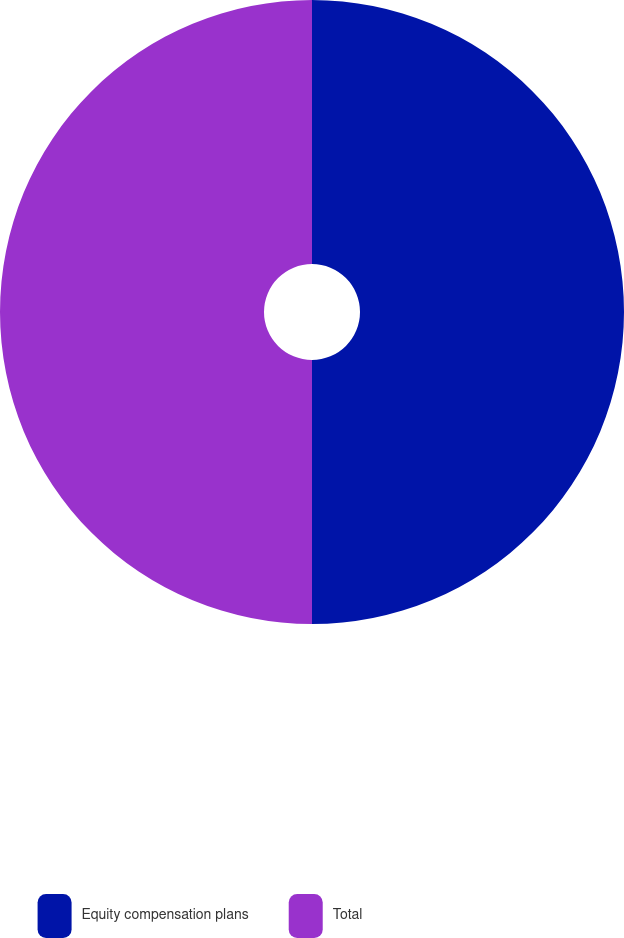Convert chart to OTSL. <chart><loc_0><loc_0><loc_500><loc_500><pie_chart><fcel>Equity compensation plans<fcel>Total<nl><fcel>50.0%<fcel>50.0%<nl></chart> 